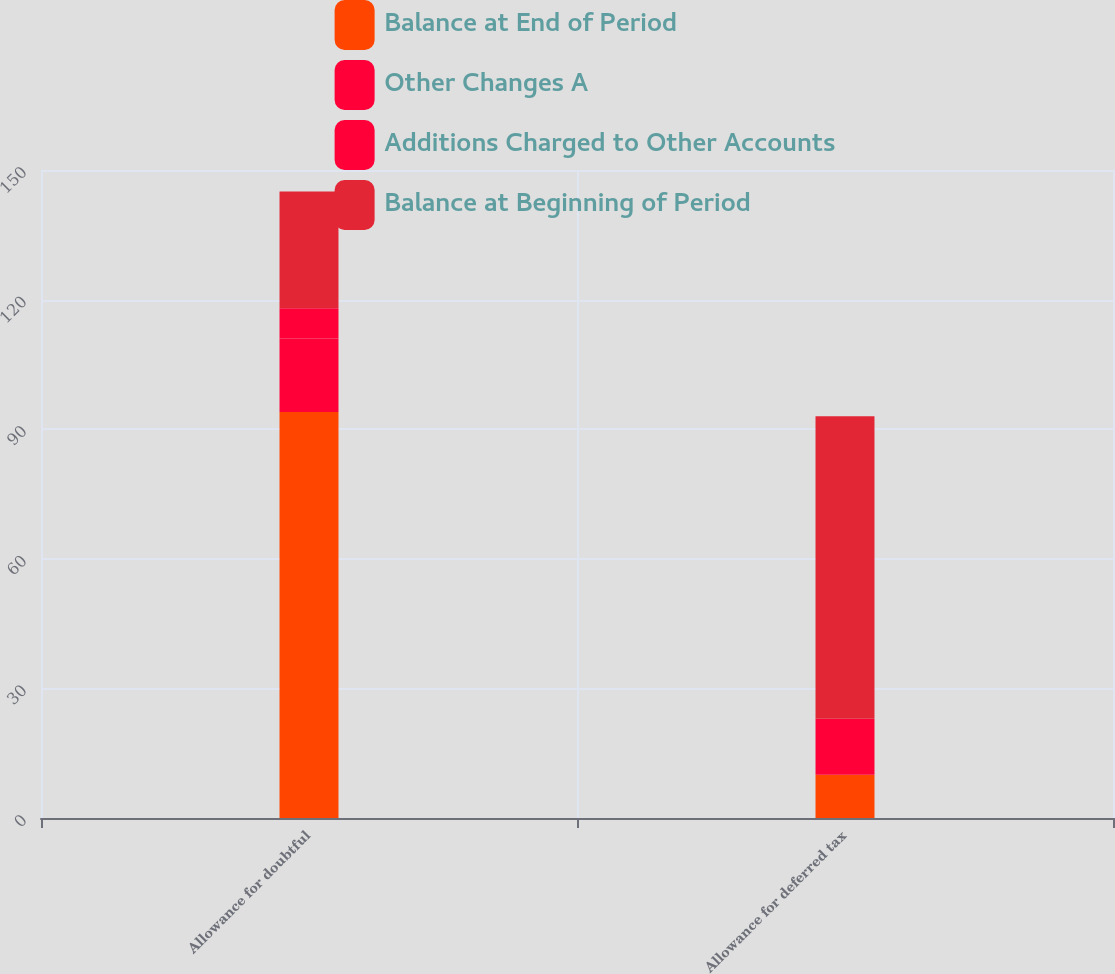Convert chart to OTSL. <chart><loc_0><loc_0><loc_500><loc_500><stacked_bar_chart><ecel><fcel>Allowance for doubtful<fcel>Allowance for deferred tax<nl><fcel>Balance at End of Period<fcel>94<fcel>10<nl><fcel>Other Changes A<fcel>17<fcel>6<nl><fcel>Additions Charged to Other Accounts<fcel>7<fcel>7<nl><fcel>Balance at Beginning of Period<fcel>27<fcel>70<nl></chart> 